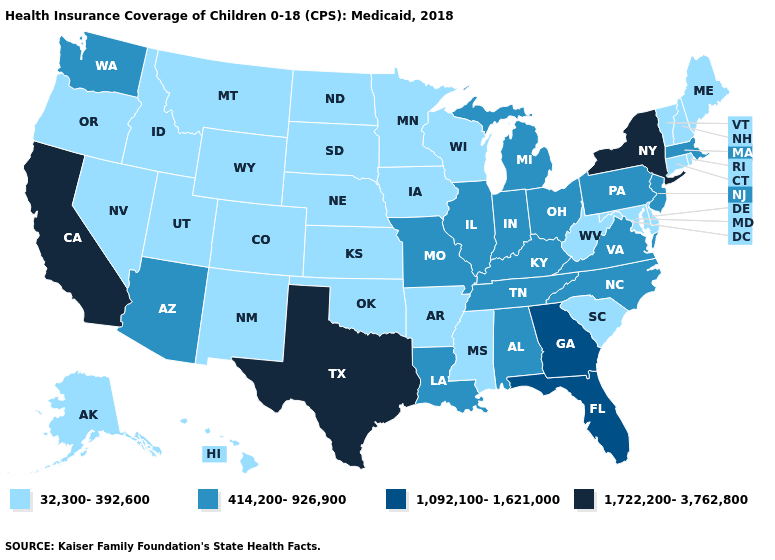What is the highest value in the Northeast ?
Give a very brief answer. 1,722,200-3,762,800. Does Hawaii have the highest value in the USA?
Be succinct. No. What is the value of Iowa?
Short answer required. 32,300-392,600. What is the highest value in the USA?
Quick response, please. 1,722,200-3,762,800. What is the value of Maryland?
Be succinct. 32,300-392,600. Among the states that border Illinois , which have the highest value?
Concise answer only. Indiana, Kentucky, Missouri. What is the lowest value in the USA?
Concise answer only. 32,300-392,600. What is the lowest value in the USA?
Answer briefly. 32,300-392,600. What is the lowest value in states that border Nevada?
Short answer required. 32,300-392,600. Does Texas have the highest value in the USA?
Answer briefly. Yes. What is the value of Alabama?
Be succinct. 414,200-926,900. What is the highest value in the USA?
Be succinct. 1,722,200-3,762,800. What is the value of Massachusetts?
Keep it brief. 414,200-926,900. Which states have the highest value in the USA?
Answer briefly. California, New York, Texas. What is the highest value in states that border North Dakota?
Short answer required. 32,300-392,600. 